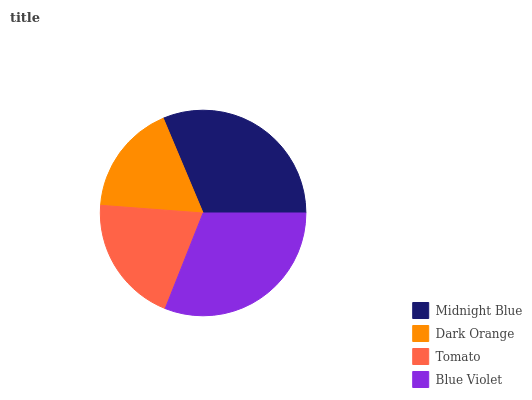Is Dark Orange the minimum?
Answer yes or no. Yes. Is Midnight Blue the maximum?
Answer yes or no. Yes. Is Tomato the minimum?
Answer yes or no. No. Is Tomato the maximum?
Answer yes or no. No. Is Tomato greater than Dark Orange?
Answer yes or no. Yes. Is Dark Orange less than Tomato?
Answer yes or no. Yes. Is Dark Orange greater than Tomato?
Answer yes or no. No. Is Tomato less than Dark Orange?
Answer yes or no. No. Is Blue Violet the high median?
Answer yes or no. Yes. Is Tomato the low median?
Answer yes or no. Yes. Is Midnight Blue the high median?
Answer yes or no. No. Is Blue Violet the low median?
Answer yes or no. No. 